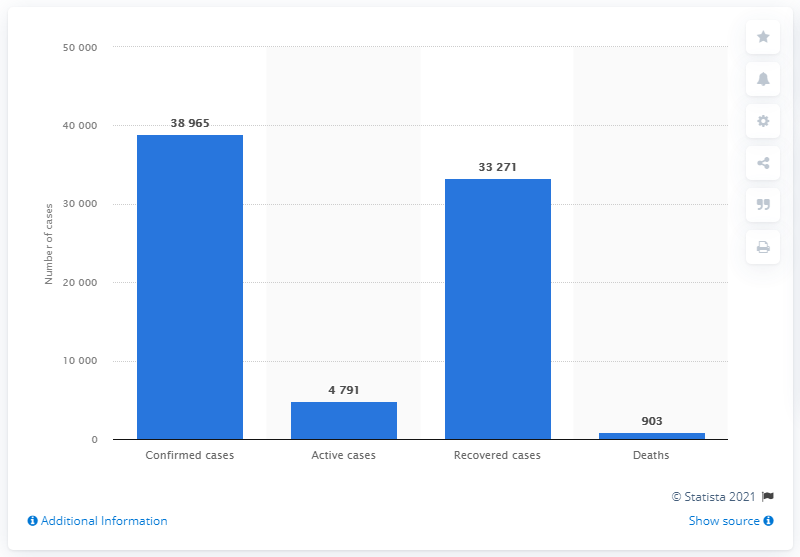List a handful of essential elements in this visual. As of July 1, 2021, a total of 903 deaths had been registered in Angola due to the coronavirus outbreak. 